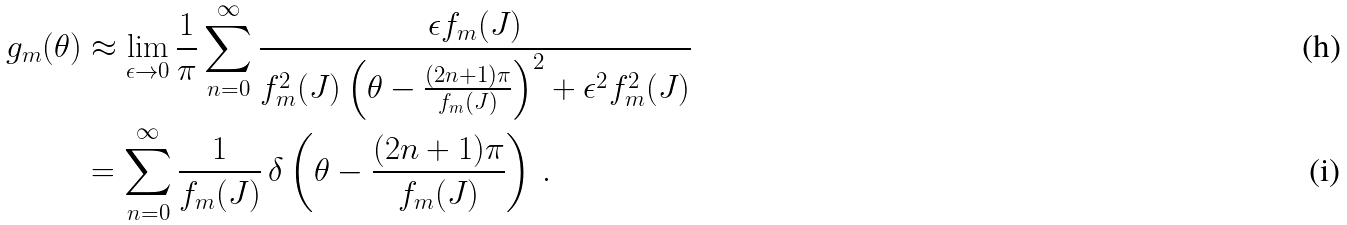<formula> <loc_0><loc_0><loc_500><loc_500>g _ { m } ( \theta ) & \approx \lim _ { \epsilon \to 0 } \frac { 1 } { \pi } \sum _ { n = 0 } ^ { \infty } \frac { \epsilon f _ { m } ( J ) } { f _ { m } ^ { 2 } ( J ) \left ( \theta - \frac { ( 2 n + 1 ) \pi } { f _ { m } ( J ) } \right ) ^ { 2 } + \epsilon ^ { 2 } f _ { m } ^ { 2 } ( J ) } \\ & = \sum _ { n = 0 } ^ { \infty } \frac { 1 } { f _ { m } ( J ) } \, \delta \left ( \theta - \frac { ( 2 n + 1 ) \pi } { f _ { m } ( J ) } \right ) \, .</formula> 